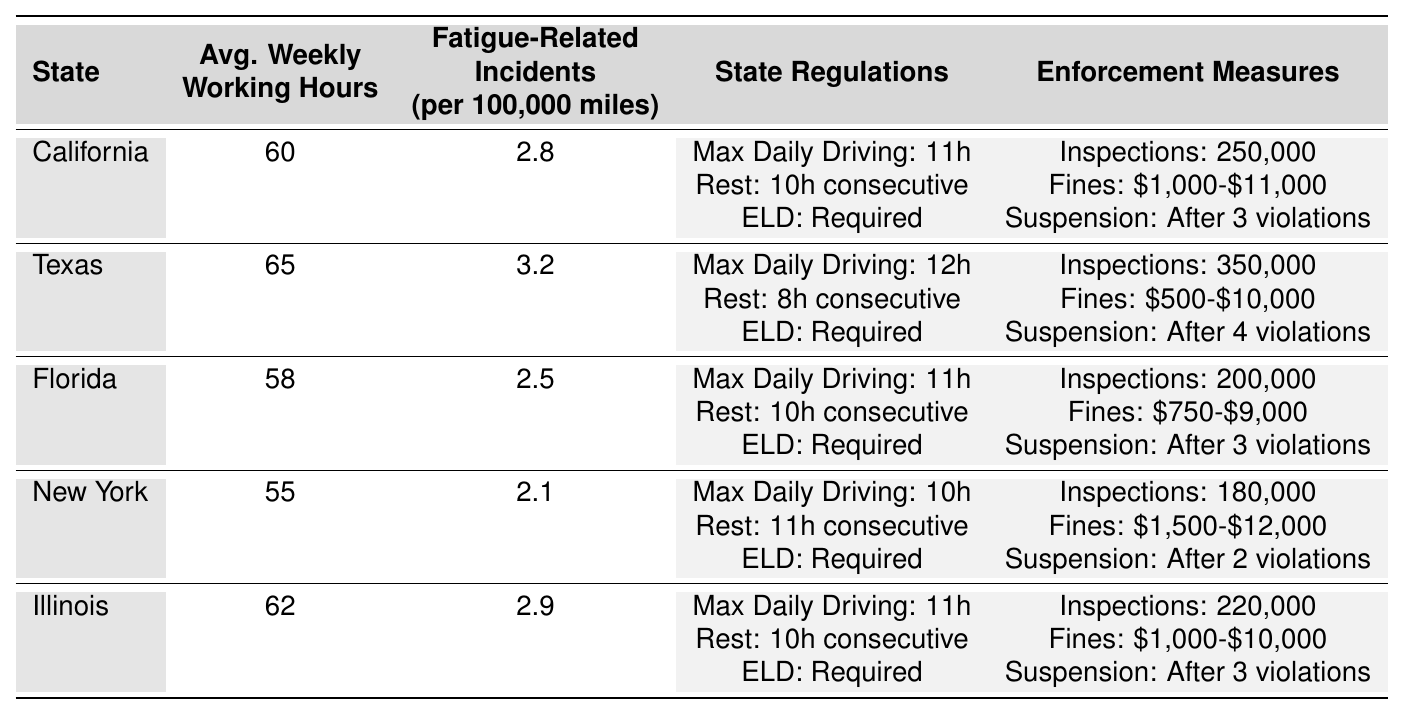What's the average weekly working hours in Texas? The table shows that the average weekly working hours in Texas is listed as 65.
Answer: 65 How many fatigue-related incidents are reported in New York per 100,000 miles? According to the table, New York has 2.1 fatigue-related incidents per 100,000 miles.
Answer: 2.1 Which state has the highest number of roadside inspections per year? The table indicates that Texas has the highest number of roadside inspections at 350,000 per year, compared to other states listed.
Answer: Texas Is Florida’s maximum daily driving hours less than California’s? California has a maximum of 11 hours while Florida also has a maximum of 11 hours, therefore the statement is false.
Answer: No What is the total number of roadside inspections conducted annually in California and Florida? California conducts 250,000 inspections and Florida conducts 200,000 inspections. So, 250,000 + 200,000 = 450,000 inspections in total.
Answer: 450000 What is the average number of fatigue-related incidents across all states listed? The incidents are 2.8 (California), 3.2 (Texas), 2.5 (Florida), 2.1 (New York), and 2.9 (Illinois). Adding these gives 13.5 inc. Divide by 5 (number of states) yields an average of 2.7.
Answer: 2.7 Which state has the most lenient license suspension policy for violations? New York has the most lenient policy, allowing up to 2 violations before suspension.
Answer: New York If a truck driver works the maximum daily hours allowed in Illinois, how many hours would they spend driving in a week? Illinois allows a maximum of 11 hours per day and if working that for 6 days a week (assuming 1 day off), that totals: 11 hours/day * 6 days = 66 hours/week.
Answer: 66 What is the difference in the number of fatigue-related incidents between Texas and New York? Texas has 3.2 incidents and New York has 2.1 incidents. The difference is 3.2 - 2.1 = 1.1 incidents.
Answer: 1.1 Does the average weekly working hours in any state exceed 65 hours? Yes, Texas has an average of 65 hours, which is equal. There is no state exceeding that.
Answer: Yes 